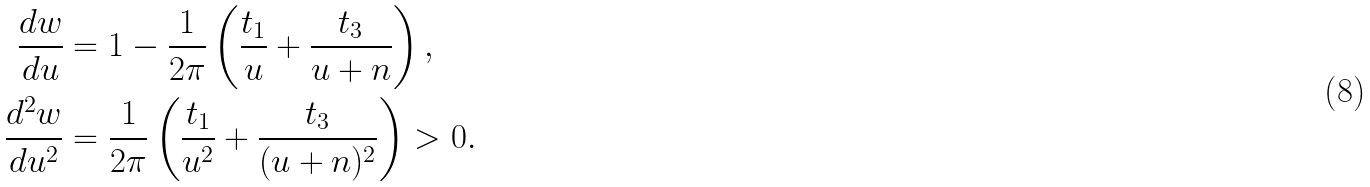Convert formula to latex. <formula><loc_0><loc_0><loc_500><loc_500>\frac { d w } { d u } & = 1 - \frac { 1 } { 2 \pi } \left ( \frac { t _ { 1 } } { u } + \frac { t _ { 3 } } { u + n } \right ) , \\ \frac { d ^ { 2 } w } { d u ^ { 2 } } & = \frac { 1 } { 2 \pi } \left ( \frac { t _ { 1 } } { u ^ { 2 } } + \frac { t _ { 3 } } { ( u + n ) ^ { 2 } } \right ) > 0 .</formula> 